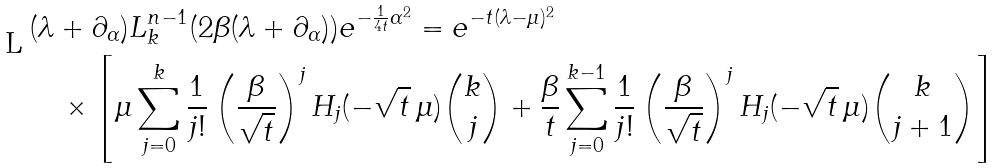<formula> <loc_0><loc_0><loc_500><loc_500>& ( \lambda + \partial _ { \alpha } ) L _ { k } ^ { n - 1 } ( 2 \beta ( \lambda + \partial _ { \alpha } ) ) e ^ { - \frac { 1 } { 4 t } \alpha ^ { 2 } } = e ^ { - t ( \lambda - \mu ) ^ { 2 } } \\ & \quad \times \left [ \mu \sum _ { j = 0 } ^ { k } \frac { 1 } { j ! } \left ( \frac { \beta } { \sqrt { t } } \right ) ^ { j } H _ { j } ( - \sqrt { t } \, \mu ) \binom { k } { j } + \frac { \beta } { t } \sum _ { j = 0 } ^ { k - 1 } \frac { 1 } { j ! } \left ( \frac { \beta } { \sqrt { t } } \right ) ^ { j } H _ { j } ( - \sqrt { t } \, \mu ) \binom { k } { j + 1 } \right ]</formula> 